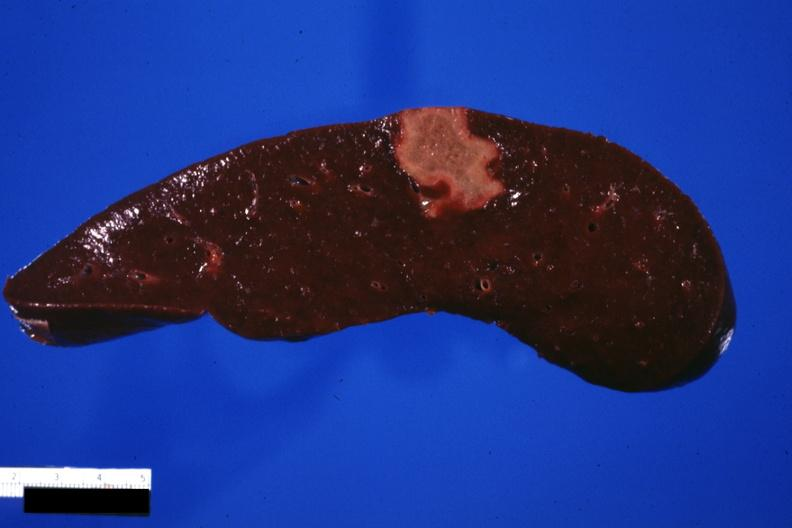does this image show cut surface of spleen with an infarct several days of age excellent photo?
Answer the question using a single word or phrase. Yes 